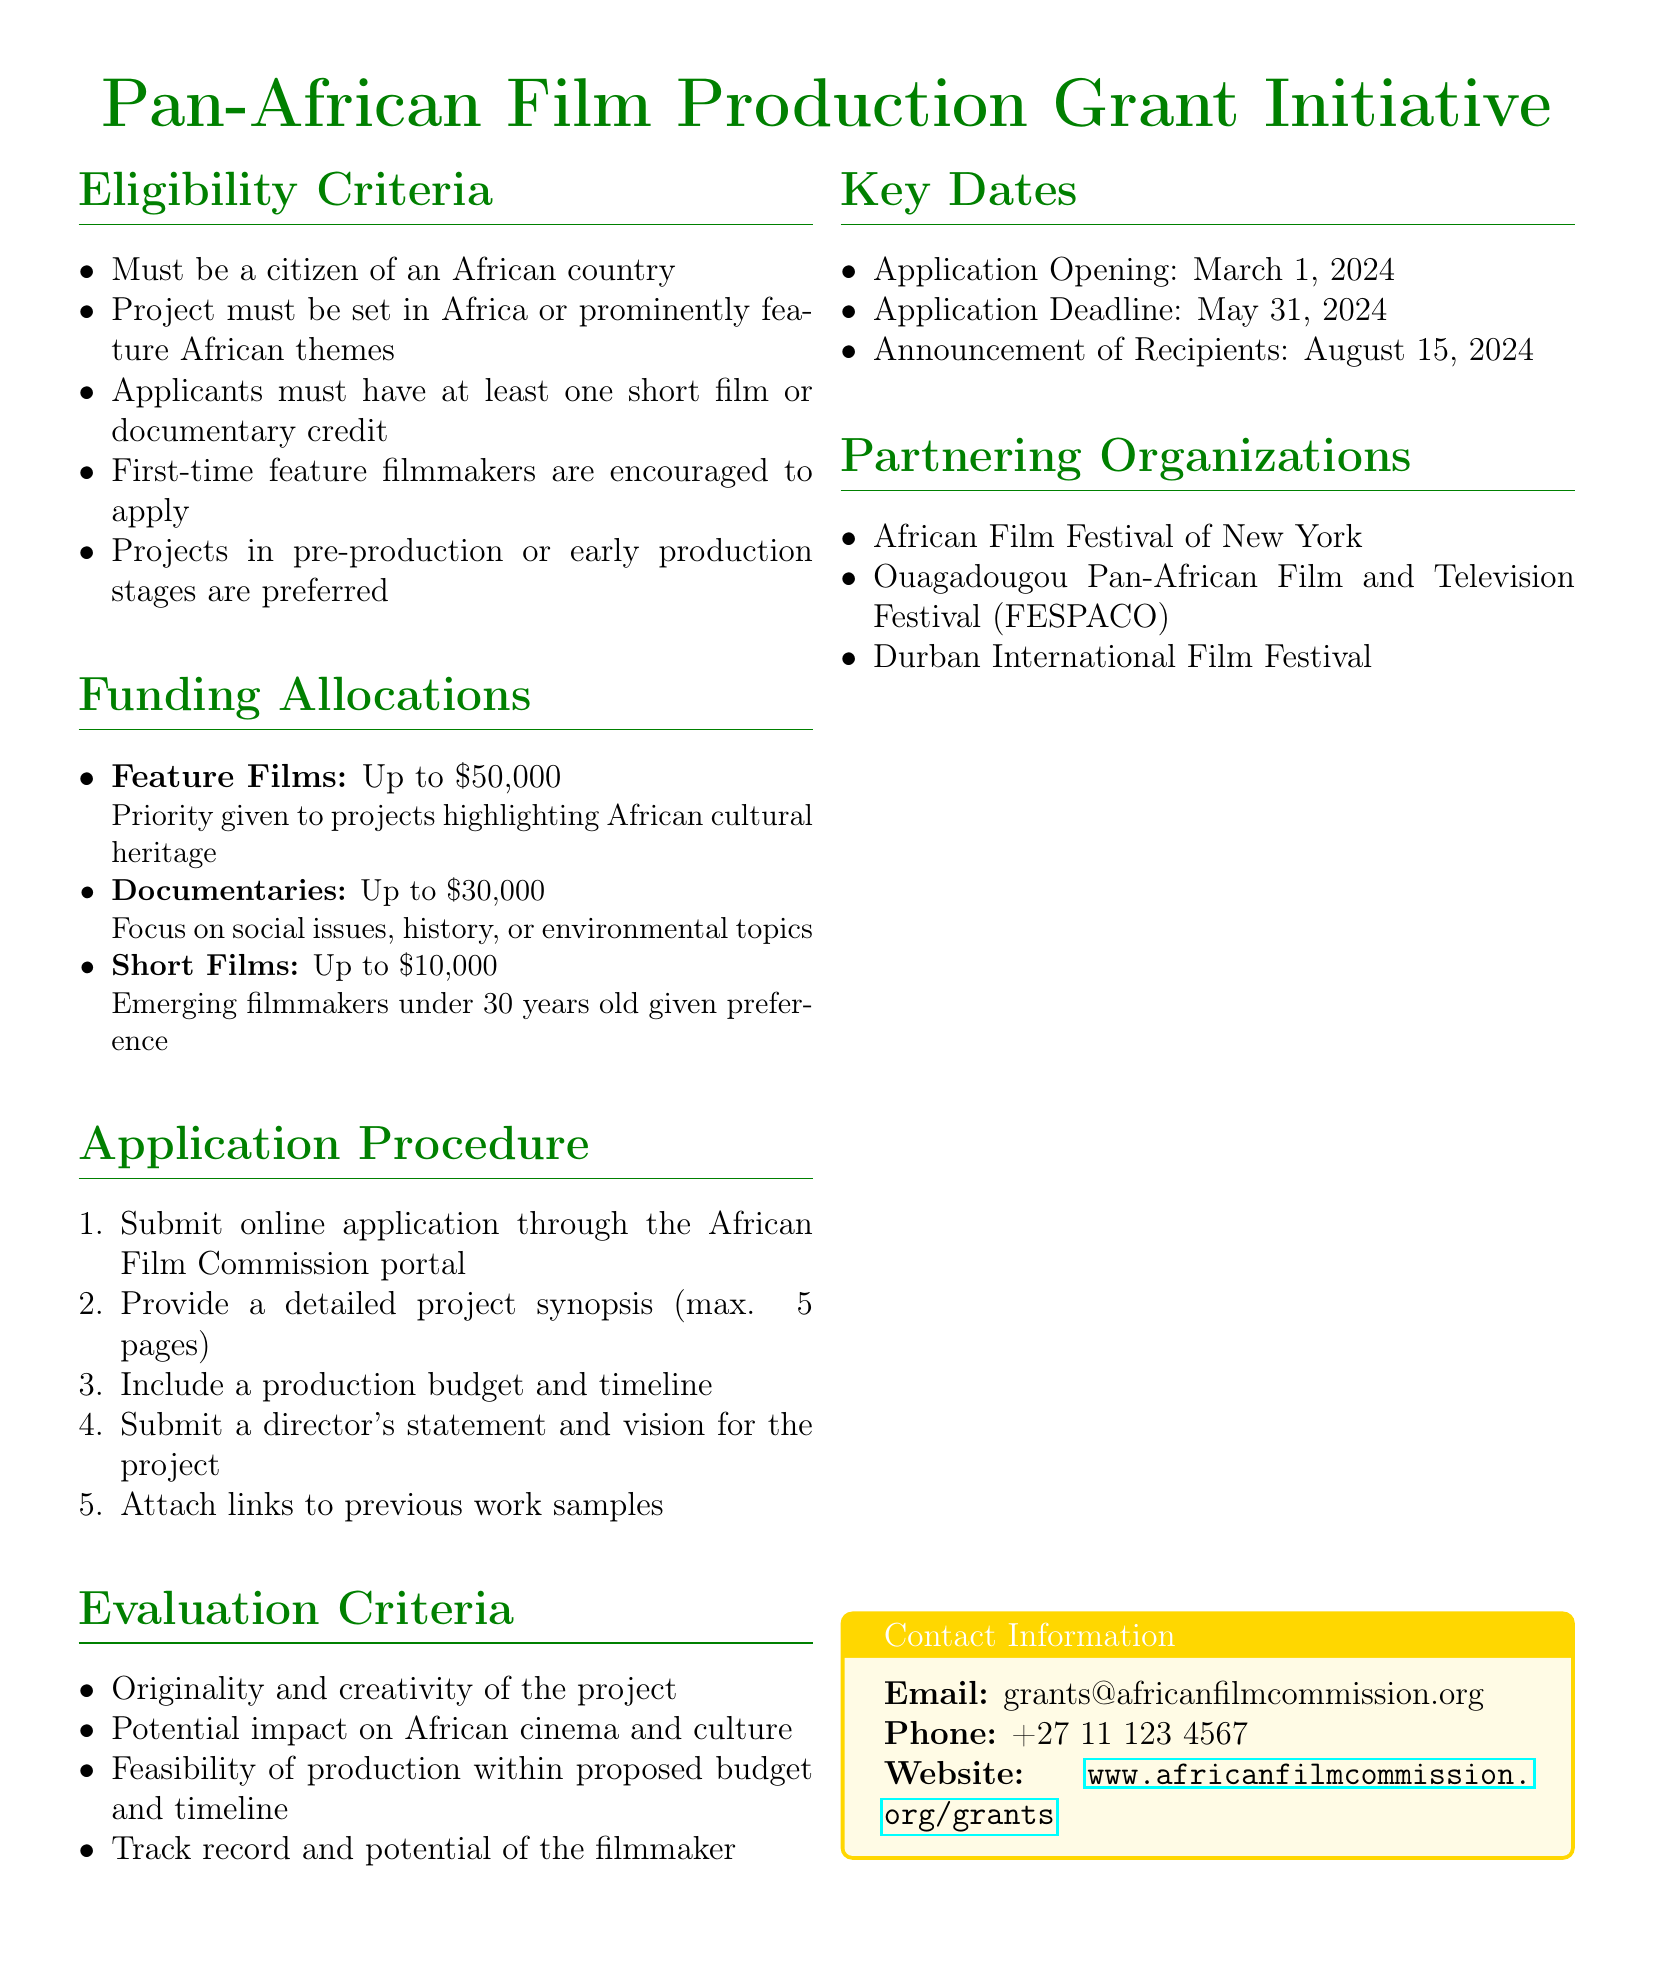What is the maximum funding for feature films? The document specifies that feature films can receive up to $50,000.
Answer: $50,000 When is the application deadline? The application deadline is stated in the key dates section of the document as May 31, 2024.
Answer: May 31, 2024 Which organization is listed as a partner? The document lists the African Film Festival of New York as one of the partnering organizations.
Answer: African Film Festival of New York What is required in the director's statement? The document mentions that the director's statement should describe the vision for the project.
Answer: Vision for the project How much funding is available for documentaries? The funding allocation for documentaries is specified as up to $30,000 in the document.
Answer: $30,000 What eligibility requirement encourages first-time filmmakers? The document highlights that first-time feature filmmakers are encouraged to apply.
Answer: First-time feature filmmakers What is the maximum length for the project synopsis? The document states that the project synopsis should have a maximum length of 5 pages.
Answer: 5 pages What type of projects are preferred according to eligibility criteria? The document indicates that projects in pre-production or early production stages are preferred.
Answer: Pre-production or early production stages 